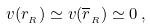<formula> <loc_0><loc_0><loc_500><loc_500>v ( r _ { _ { R } } ) \simeq v ( \overline { r } _ { _ { R } } ) \simeq 0 \, ,</formula> 